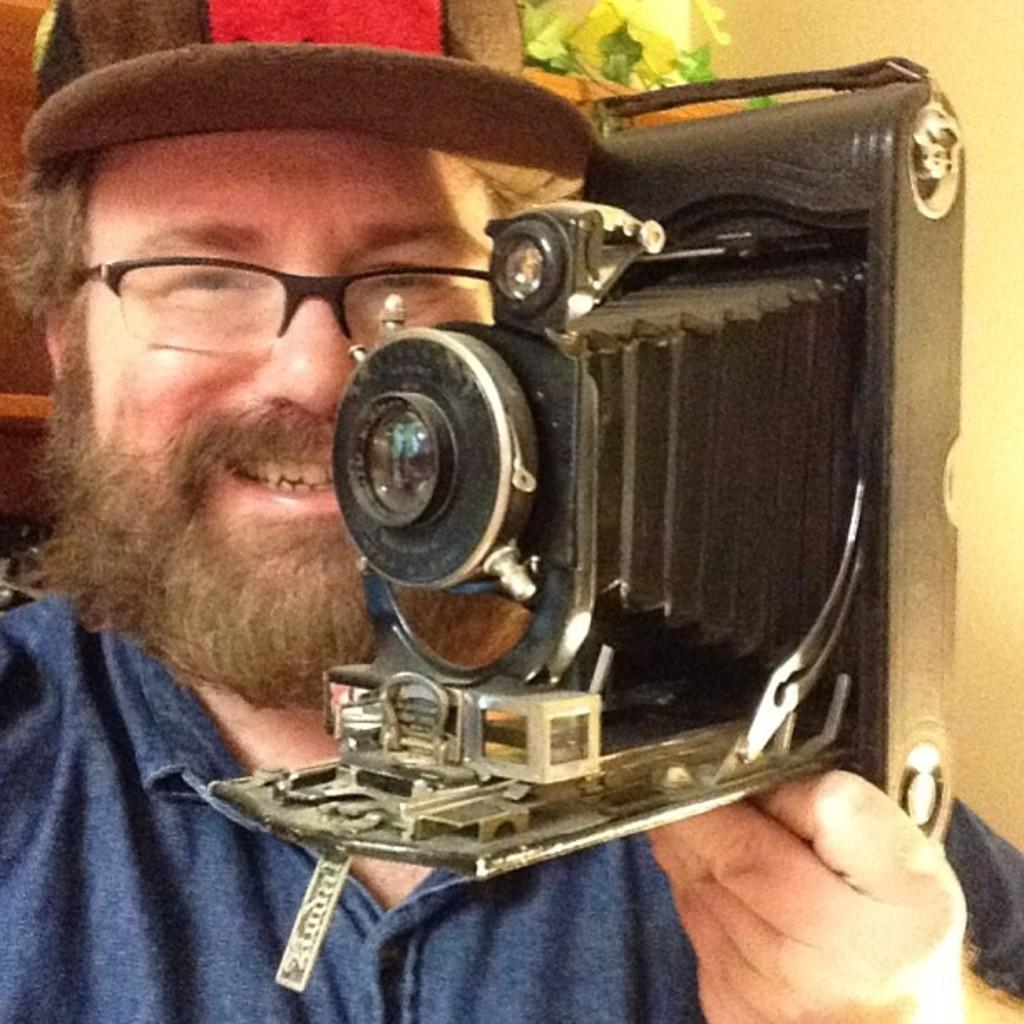What is the main subject of the image? There is a man in the image. What is the man doing in the image? The man is standing and smiling. What is the man holding in his hands? The man is holding a camera in his hands. What can be seen in the background of the image? There is a wall in the background of the image. What type of prose is being recited by the man in the image? There is no indication in the image that the man is reciting any prose or poetry. Can you see any spots on the man's clothing in the image? The image does not provide enough detail to determine if there are any spots on the man's clothing. 